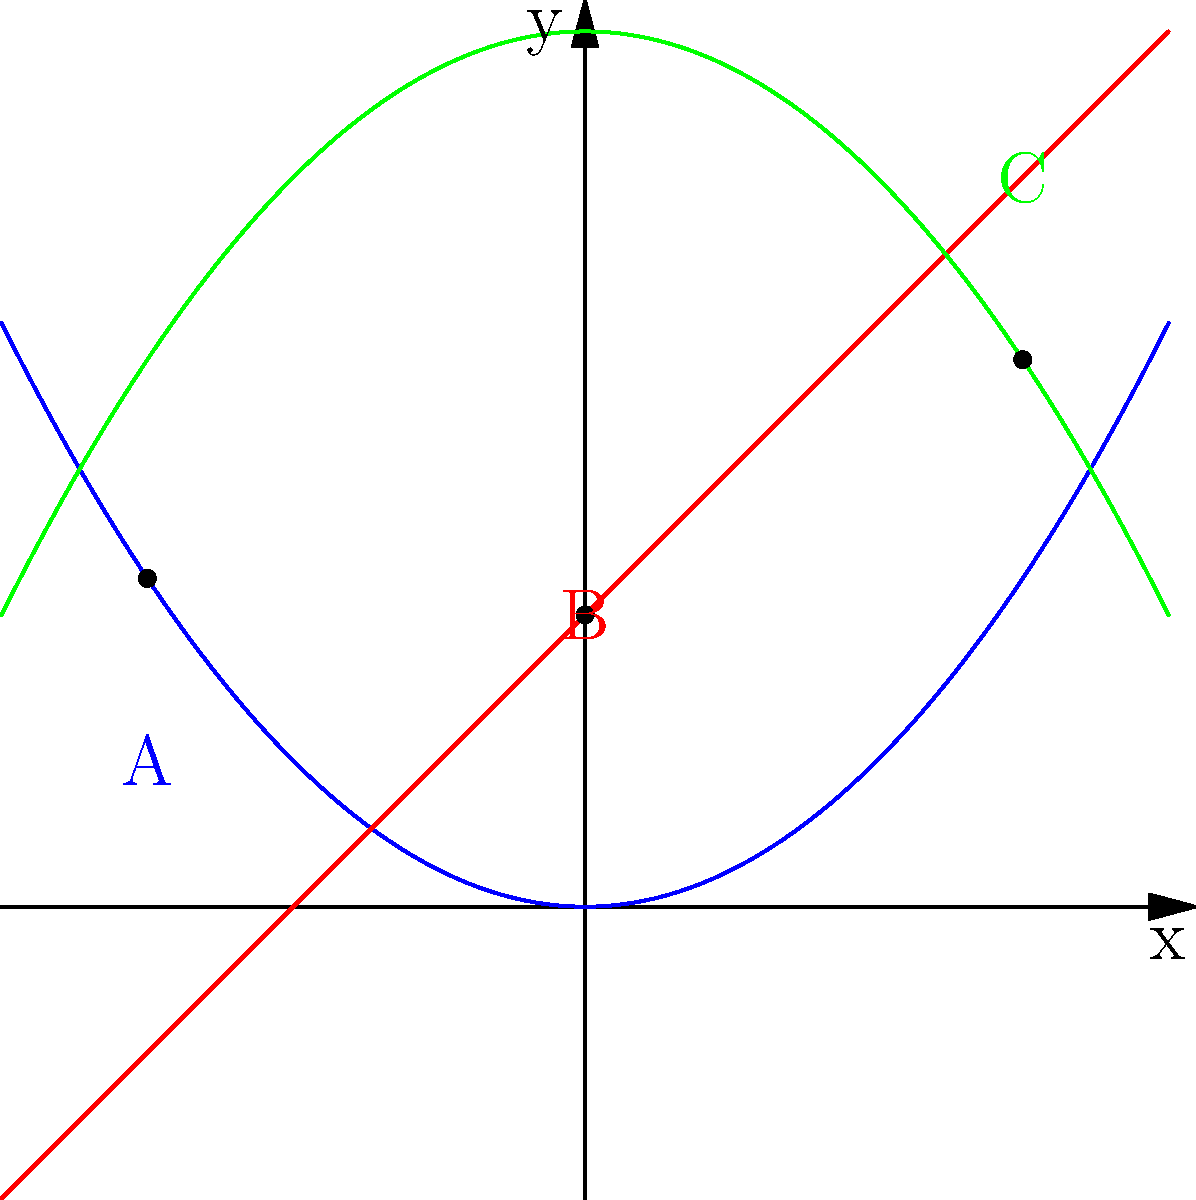Consider the topological space representing animal habitats shown in the graph. The blue curve represents grassland, the red line represents forest, and the green curve represents wetland. Points A, B, and C are specific locations within these habitats. Which of these habitats forms a connected subspace in this topological representation, and what ecological implications does this have for species distribution? To answer this question, we need to analyze the connectedness of each habitat in the given topological space:

1. Grassland (blue curve):
   The grassland habitat is represented by a continuous, unbroken curve (f1). It forms a connected subspace as there are no gaps or discontinuities.

2. Forest (red line):
   The forest habitat is represented by a straight line (f2), which is also continuous and unbroken. It forms a connected subspace.

3. Wetland (green curve):
   The wetland habitat is represented by another continuous, unbroken curve (f3). It also forms a connected subspace.

All three habitats are individually connected subspaces in this topological representation. However, they do not intersect with each other, which means they form separate connected components in the overall space.

Ecological implications:
1. Species adapted to a specific habitat can move freely within that habitat's connected subspace.
2. There are clear boundaries between habitats, which may act as barriers for species movement.
3. Species specialized for one habitat type may find it challenging to cross into another habitat, leading to isolation of populations.
4. Edge effects may occur at the boundaries between habitats, potentially creating unique microhabitats.
5. Conservation efforts may need to focus on maintaining the continuity within each habitat type to preserve species distribution.
6. Fragmentation of any of these habitats could disrupt the connectedness and negatively impact species movement and distribution.
Answer: All three habitats (grassland, forest, wetland) form connected subspaces, implying continuous species distribution within each habitat but potential isolation between habitats. 